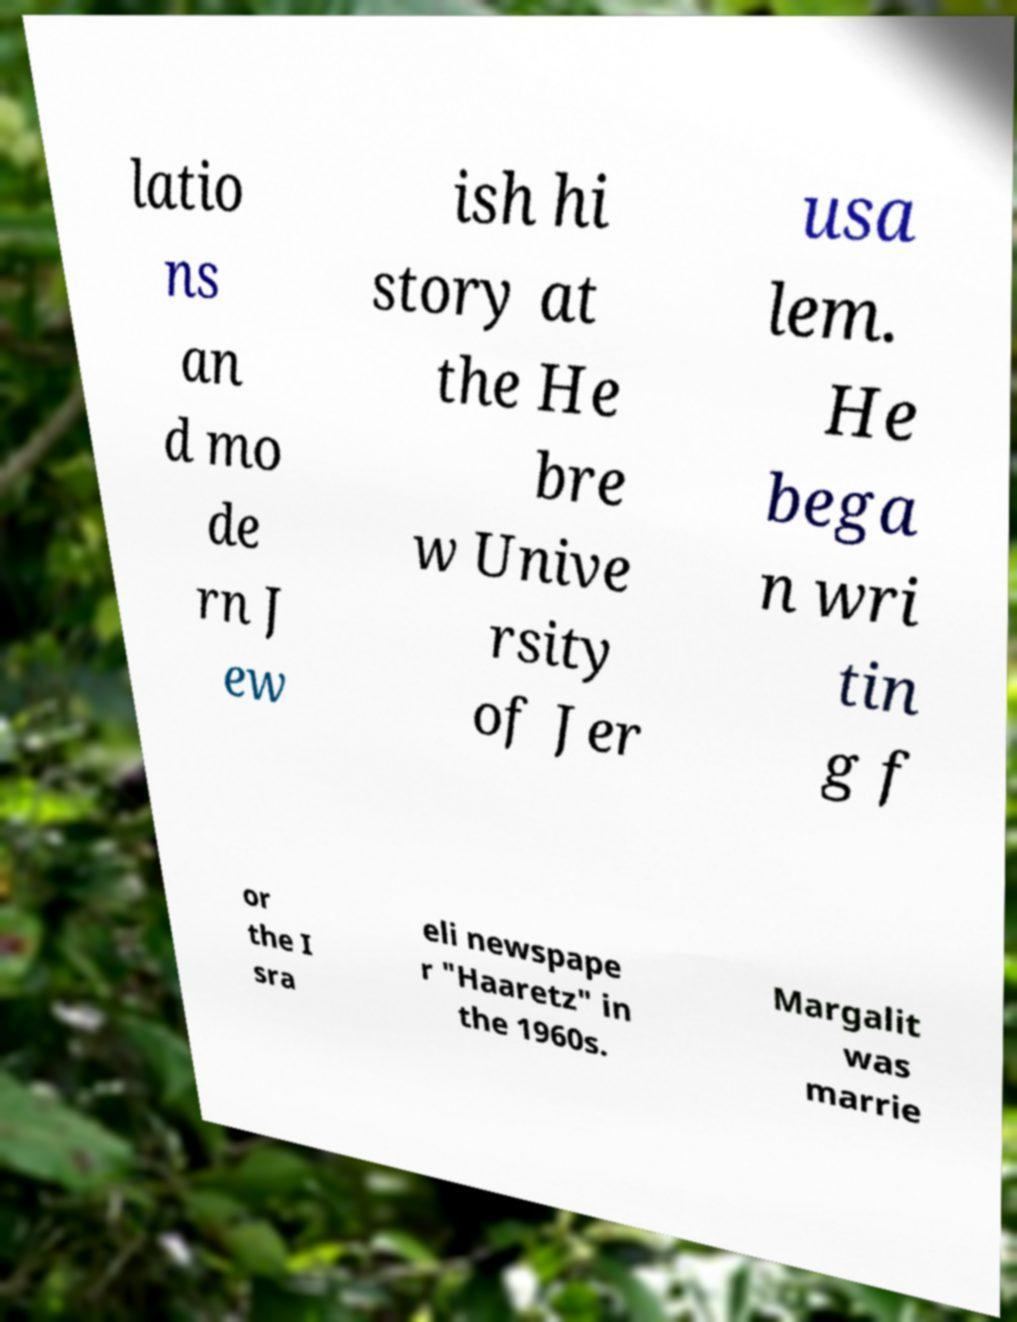What messages or text are displayed in this image? I need them in a readable, typed format. latio ns an d mo de rn J ew ish hi story at the He bre w Unive rsity of Jer usa lem. He bega n wri tin g f or the I sra eli newspape r "Haaretz" in the 1960s. Margalit was marrie 